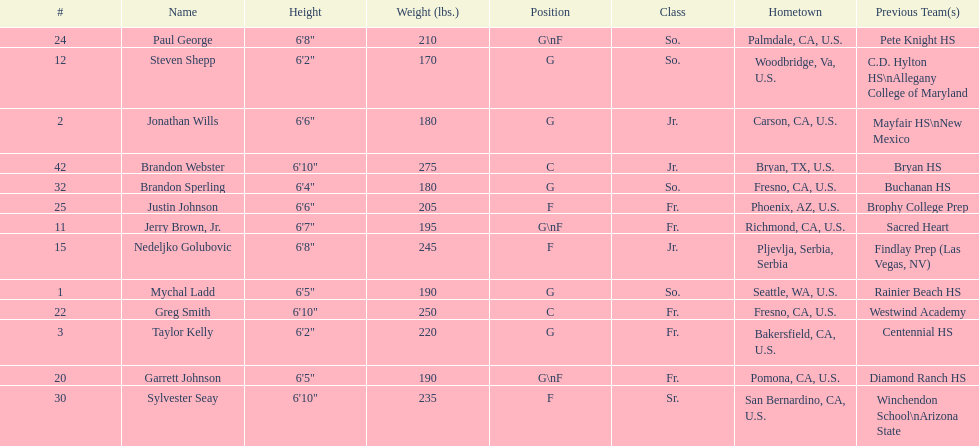Who weighs the most on the team? Brandon Webster. 